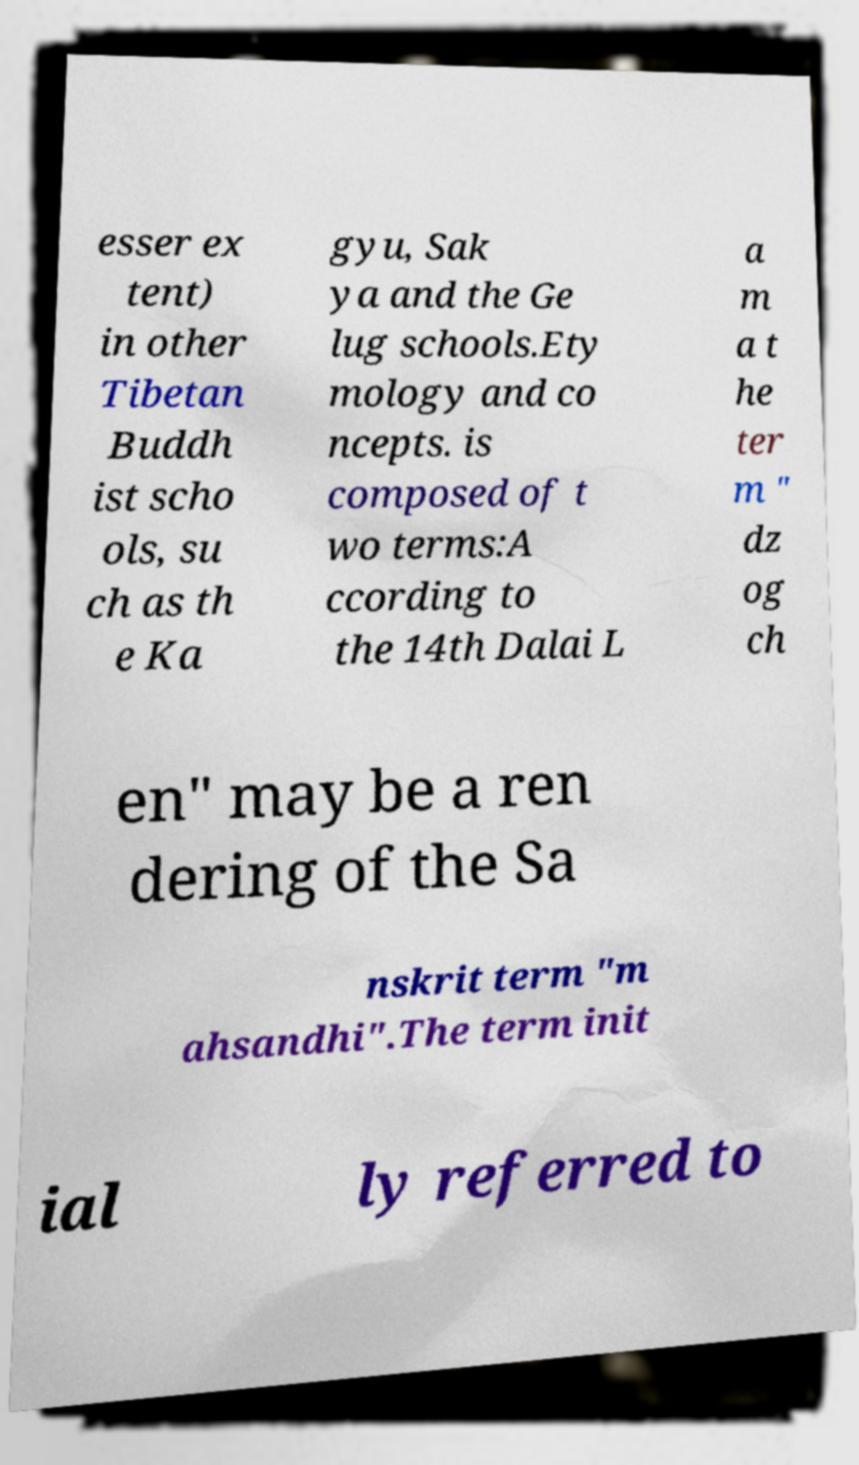I need the written content from this picture converted into text. Can you do that? esser ex tent) in other Tibetan Buddh ist scho ols, su ch as th e Ka gyu, Sak ya and the Ge lug schools.Ety mology and co ncepts. is composed of t wo terms:A ccording to the 14th Dalai L a m a t he ter m " dz og ch en" may be a ren dering of the Sa nskrit term "m ahsandhi".The term init ial ly referred to 